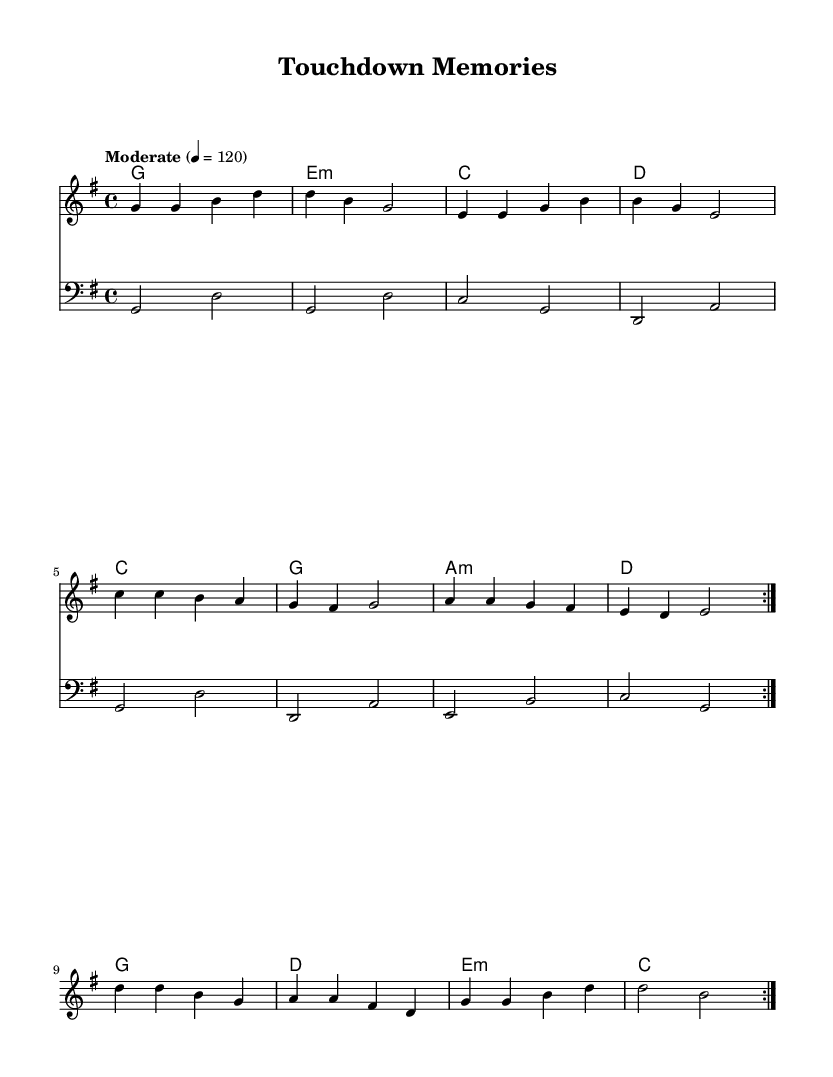What is the key signature of this music? The key signature is identified by the number of sharps or flats at the beginning of the staff. In this sheet music, there are no sharps or flats indicated, which corresponds to the key of G major.
Answer: G major What is the time signature of this music? The time signature is shown in the beginning of the staff and indicates the number of beats in a measure. This music has a time signature of 4/4, meaning there are four beats per measure.
Answer: 4/4 What is the tempo marking in this music? The tempo marking is indicated above the staff and describes the speed of the piece. In this case, it states "Moderate" with a given speed of 4 = 120, meaning there are 120 beats per minute.
Answer: Moderate 4 = 120 How many measures are in the melody section? To find the number of measures, we need to count the distinct groupings of notes separated by bars. The melody repeats a section twice, and each repeat contains 10 measures, totaling 20 measures.
Answer: 20 What is the first chord in the harmonies section? The first chord is found at the beginning of the harmonies line. The first chord indicated is G major, showing the fundamental note and structure of the chord.
Answer: G What type of influence is demonstrated in this music? The musical influences can be identified through the sound and style. This piece blends 1960s American rock influences with modern K-Pop elements, combining a nostalgic feel with contemporary pop sounds.
Answer: 1960s American rock How is the bassline structured throughout the piece? The bassline follows a consistent pattern and repeats the same 8-note sequence twice, mirroring the structure of the melody and harmonies. This repetitive structure is common in K-Pop, enhancing the song's catchiness.
Answer: Repetitive 